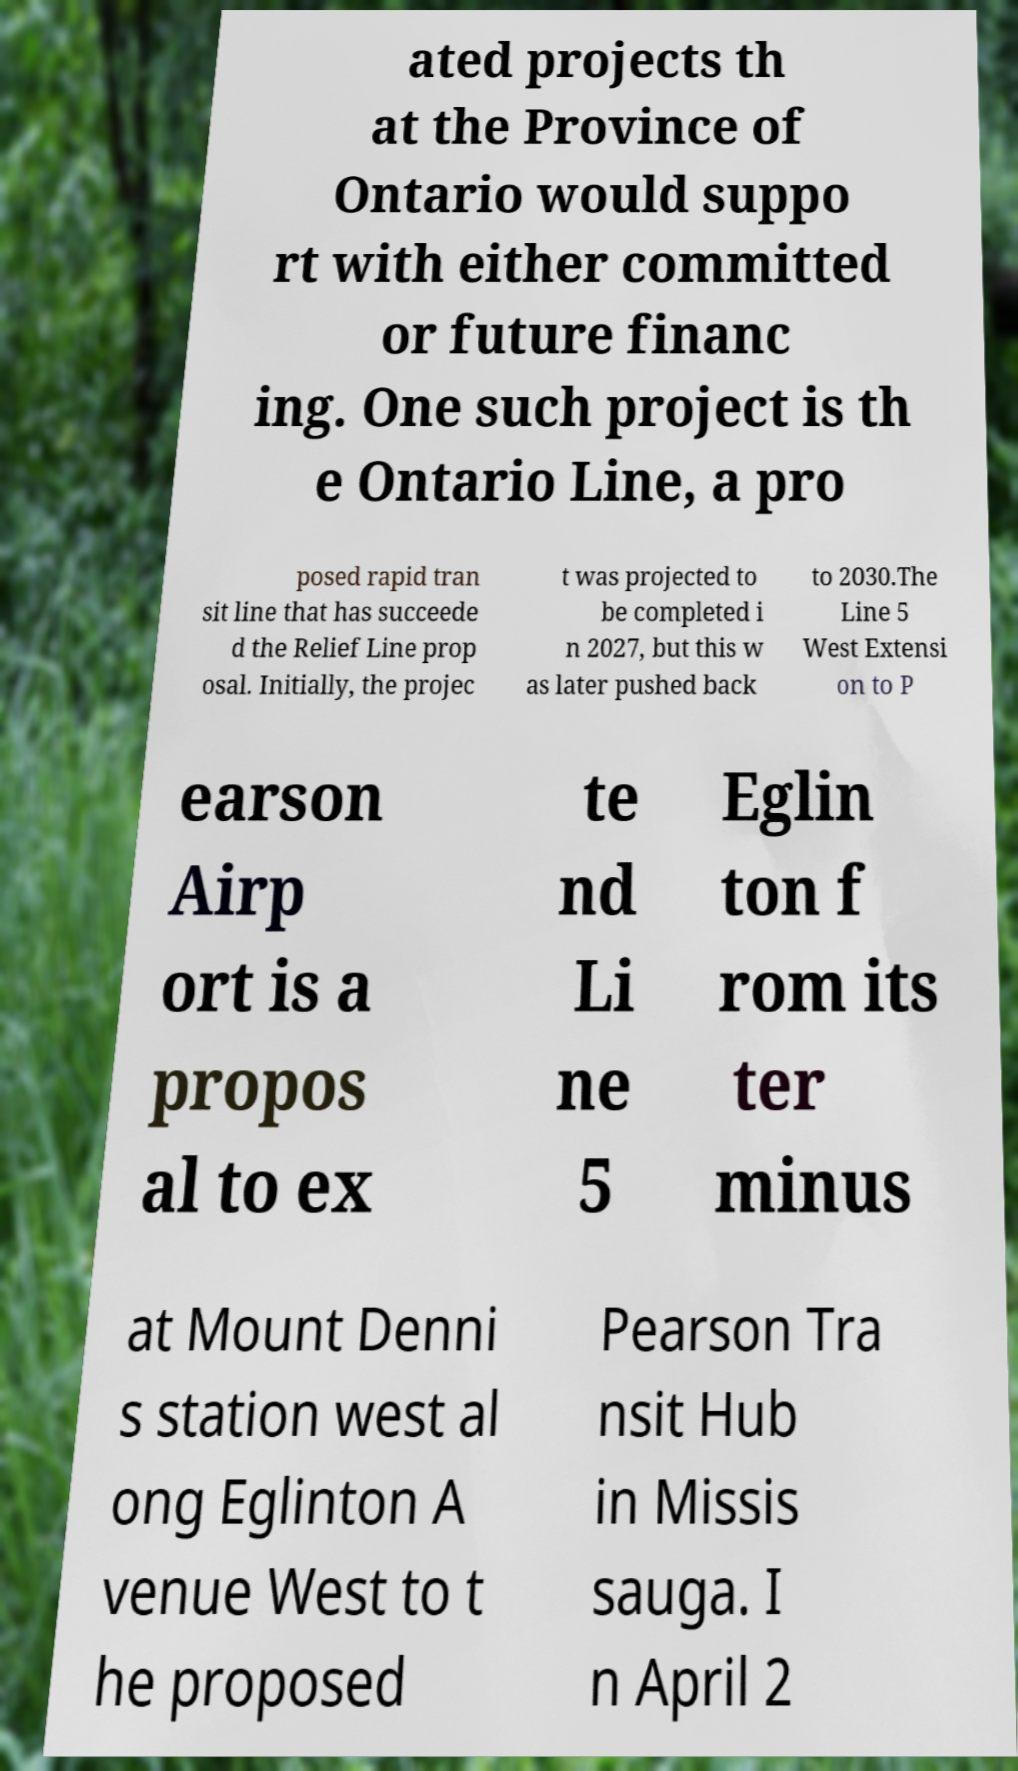Can you accurately transcribe the text from the provided image for me? ated projects th at the Province of Ontario would suppo rt with either committed or future financ ing. One such project is th e Ontario Line, a pro posed rapid tran sit line that has succeede d the Relief Line prop osal. Initially, the projec t was projected to be completed i n 2027, but this w as later pushed back to 2030.The Line 5 West Extensi on to P earson Airp ort is a propos al to ex te nd Li ne 5 Eglin ton f rom its ter minus at Mount Denni s station west al ong Eglinton A venue West to t he proposed Pearson Tra nsit Hub in Missis sauga. I n April 2 